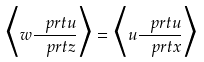<formula> <loc_0><loc_0><loc_500><loc_500>\Big { \langle } w \frac { \ p r t u } { \ p r t z } \Big { \rangle } = \Big { \langle } u \frac { \ p r t u } { \ p r t x } \Big { \rangle }</formula> 